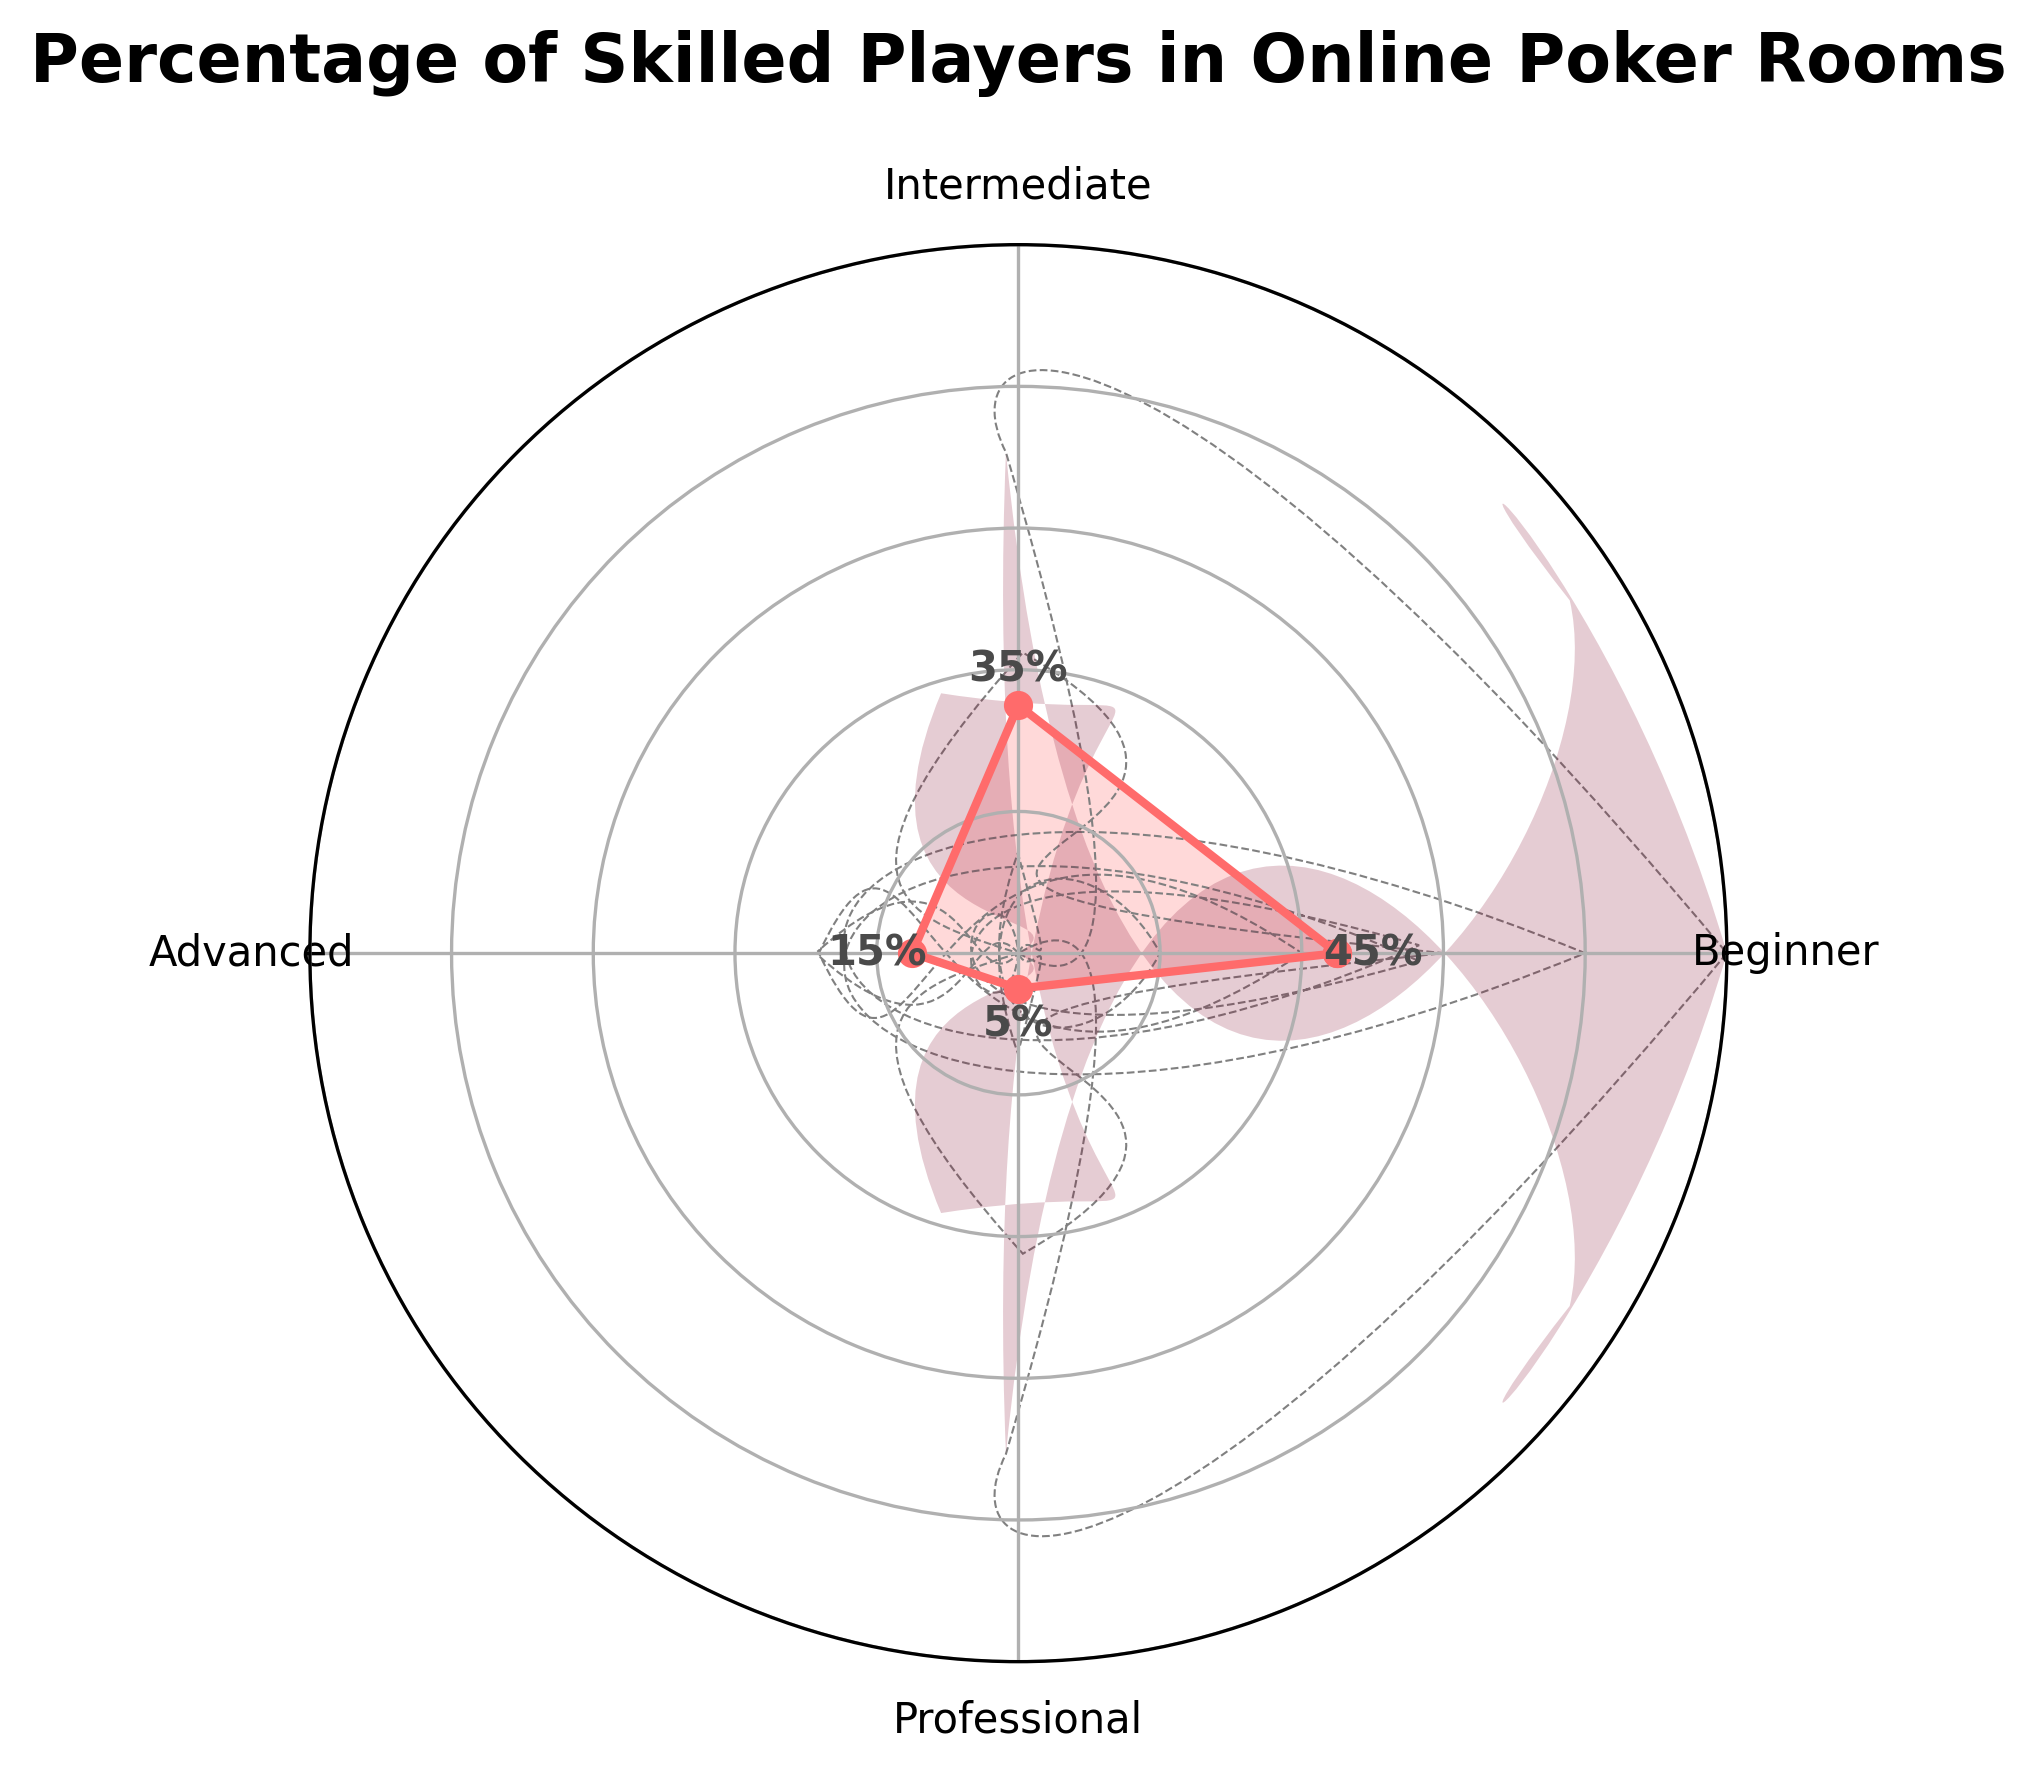What is the title of the chart? The title is typically displayed at the top of the chart where it is clearly visible. In this case, the title reads "Percentage of Skilled Players in Online Poker Rooms".
Answer: Percentage of Skilled Players in Online Poker Rooms How many categories are displayed on the chart? By looking at the labels around the chart, we can see there are four categories: Beginner, Intermediate, Advanced, and Professional.
Answer: 4 Which category has the highest percentage value? The visual length of each line corresponds to a percentage value. Beginner has the longest line, marked at 45%, making it the highest.
Answer: Beginner What is the combined percentage of Intermediate and Advanced players? Sum the values of Intermediate (35%) and Advanced (15%). 35% + 15% = 50%
Answer: 50% How much higher is the percentage of Beginner players compared to Professional players? Subtract the percentage of Professional (5%) from the Beginner (45%). 45% - 5% = 40%
Answer: 40% Which category has the smallest percentage? By checking the lowest point marked on the chart, Professional has the smallest percentage at 5%.
Answer: Professional What are the percentage values for each category displayed? The text annotations on the chart indicate the percentages for each category: Beginner (45%), Intermediate (35%), Advanced (15%), and Professional (5%).
Answer: Beginner: 45%, Intermediate: 35%, Advanced: 15%, Professional: 5% How does the percentage of Advanced players compare to the percentage of Intermediate players? By comparing the values, Advanced players (15%) have a lower percentage than Intermediate players (35%).
Answer: Advanced is lower than Intermediate If we grouped Intermediate and Advanced players together, what percentage of the total would they represent? Adding the percentages of Intermediate (35%) and Advanced (15%), we get 50%. Therefore, Intermediate and Advanced together represent 50% of the total.
Answer: 50% Based on the chart, what conclusions can be drawn about the distribution of skill levels in online poker rooms? Beginner players have the highest representation at 45%, followed by Intermediate (35%). Advanced and Professional players make up a smaller portion, 15% and 5%, respectively. This indicates a larger presence of lower-skilled players in online poker rooms.
Answer: More lower-skilled players compared to higher-skilled players 